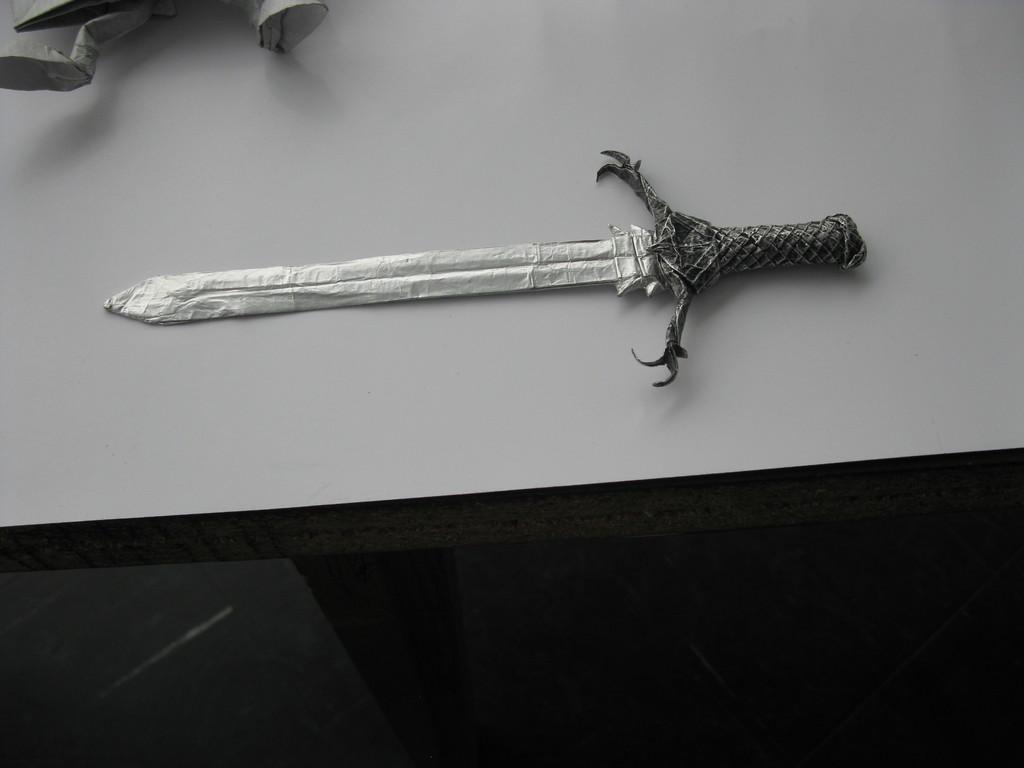What is the color scheme of the image? The image is black and white. What type of paper craft can be seen in the image? There is a sword made of paper in the image. Where is the paper sword located? The sword is placed on a table. What else can be seen in the image besides the paper sword? There is another paper craft visible at the top of the image. Can you hear the paper sword cry in the image? There is no sound in the image, and paper swords do not have the ability to cry. 